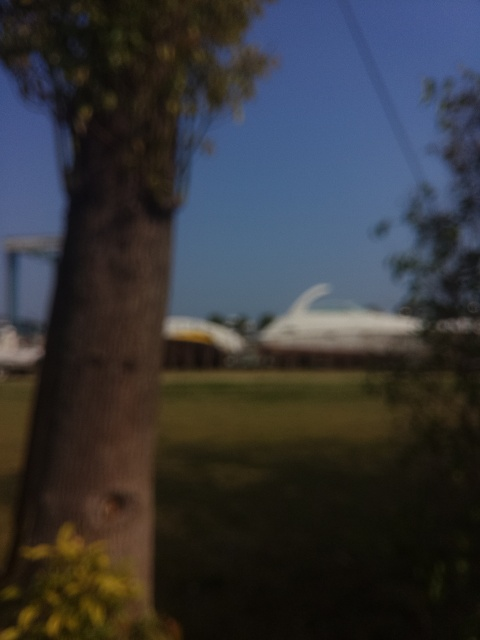Can you describe the feeling this image evokes with its blurred scenery? The image's blurred elements combine to evoke a sense of nostalgia and tranquility, perhaps suggesting a moment captured in motion, or a memory that is fading, akin to the way details slip from one's grasp in a dream. 